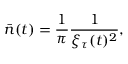Convert formula to latex. <formula><loc_0><loc_0><loc_500><loc_500>{ \bar { n } } ( t ) = \frac { 1 } { \pi } \frac { 1 } { \xi _ { \tau } ( t ) ^ { 2 } } ,</formula> 